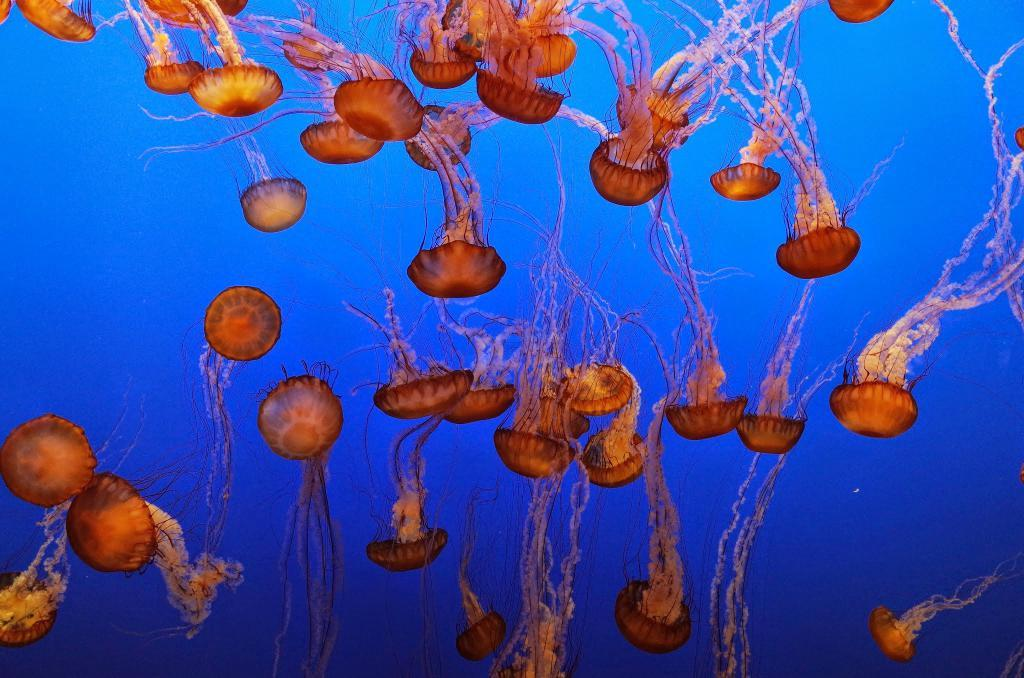What type of animals can be seen in the water in the image? There are many jellyfishes in the water. Can you describe the environment in which the jellyfishes are located? The jellyfishes are located in the water. What type of cactus can be seen growing in the water in the image? There is no cactus present in the image; it features many jellyfishes in the water. 